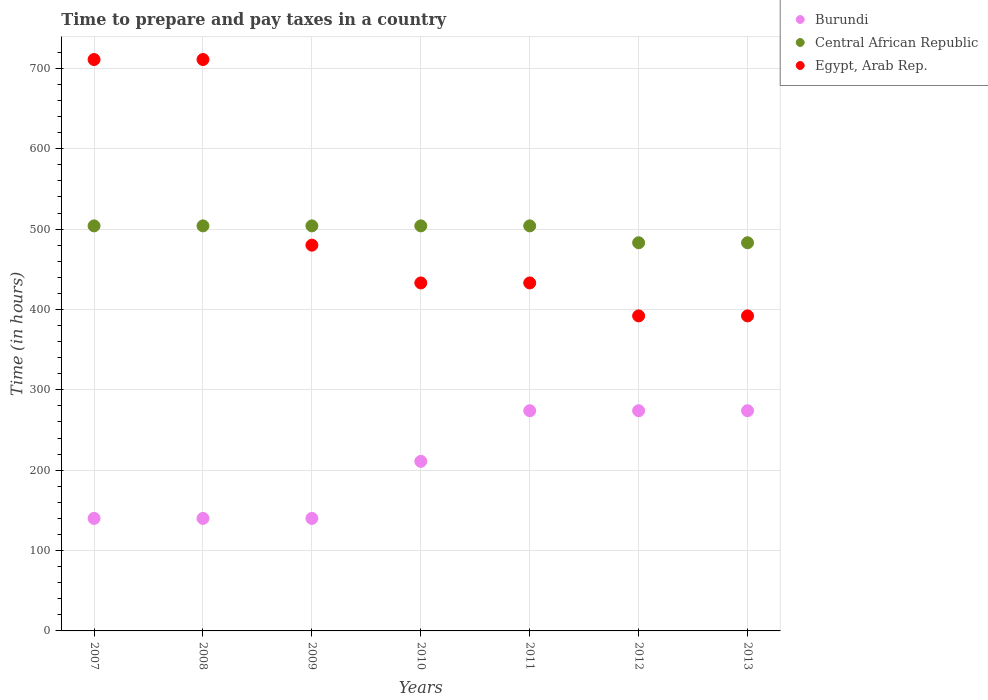Is the number of dotlines equal to the number of legend labels?
Offer a terse response. Yes. What is the number of hours required to prepare and pay taxes in Burundi in 2012?
Give a very brief answer. 274. Across all years, what is the maximum number of hours required to prepare and pay taxes in Egypt, Arab Rep.?
Your answer should be very brief. 711. Across all years, what is the minimum number of hours required to prepare and pay taxes in Burundi?
Ensure brevity in your answer.  140. In which year was the number of hours required to prepare and pay taxes in Burundi minimum?
Ensure brevity in your answer.  2007. What is the total number of hours required to prepare and pay taxes in Burundi in the graph?
Your answer should be compact. 1453. What is the difference between the number of hours required to prepare and pay taxes in Egypt, Arab Rep. in 2008 and that in 2011?
Provide a short and direct response. 278. What is the difference between the number of hours required to prepare and pay taxes in Egypt, Arab Rep. in 2008 and the number of hours required to prepare and pay taxes in Central African Republic in 2010?
Keep it short and to the point. 207. What is the average number of hours required to prepare and pay taxes in Burundi per year?
Provide a succinct answer. 207.57. In the year 2013, what is the difference between the number of hours required to prepare and pay taxes in Central African Republic and number of hours required to prepare and pay taxes in Egypt, Arab Rep.?
Offer a very short reply. 91. What is the ratio of the number of hours required to prepare and pay taxes in Burundi in 2010 to that in 2011?
Provide a short and direct response. 0.77. Is the difference between the number of hours required to prepare and pay taxes in Central African Republic in 2008 and 2010 greater than the difference between the number of hours required to prepare and pay taxes in Egypt, Arab Rep. in 2008 and 2010?
Your response must be concise. No. What is the difference between the highest and the second highest number of hours required to prepare and pay taxes in Burundi?
Provide a succinct answer. 0. What is the difference between the highest and the lowest number of hours required to prepare and pay taxes in Burundi?
Keep it short and to the point. 134. In how many years, is the number of hours required to prepare and pay taxes in Burundi greater than the average number of hours required to prepare and pay taxes in Burundi taken over all years?
Give a very brief answer. 4. Does the number of hours required to prepare and pay taxes in Egypt, Arab Rep. monotonically increase over the years?
Your response must be concise. No. Is the number of hours required to prepare and pay taxes in Burundi strictly greater than the number of hours required to prepare and pay taxes in Egypt, Arab Rep. over the years?
Make the answer very short. No. Is the number of hours required to prepare and pay taxes in Burundi strictly less than the number of hours required to prepare and pay taxes in Central African Republic over the years?
Your response must be concise. Yes. How many years are there in the graph?
Make the answer very short. 7. What is the difference between two consecutive major ticks on the Y-axis?
Give a very brief answer. 100. Are the values on the major ticks of Y-axis written in scientific E-notation?
Your response must be concise. No. Does the graph contain grids?
Make the answer very short. Yes. What is the title of the graph?
Provide a short and direct response. Time to prepare and pay taxes in a country. Does "Mauritania" appear as one of the legend labels in the graph?
Make the answer very short. No. What is the label or title of the X-axis?
Your answer should be very brief. Years. What is the label or title of the Y-axis?
Provide a succinct answer. Time (in hours). What is the Time (in hours) in Burundi in 2007?
Ensure brevity in your answer.  140. What is the Time (in hours) of Central African Republic in 2007?
Your response must be concise. 504. What is the Time (in hours) of Egypt, Arab Rep. in 2007?
Make the answer very short. 711. What is the Time (in hours) of Burundi in 2008?
Keep it short and to the point. 140. What is the Time (in hours) in Central African Republic in 2008?
Provide a succinct answer. 504. What is the Time (in hours) of Egypt, Arab Rep. in 2008?
Ensure brevity in your answer.  711. What is the Time (in hours) in Burundi in 2009?
Provide a short and direct response. 140. What is the Time (in hours) in Central African Republic in 2009?
Your answer should be very brief. 504. What is the Time (in hours) in Egypt, Arab Rep. in 2009?
Offer a terse response. 480. What is the Time (in hours) of Burundi in 2010?
Keep it short and to the point. 211. What is the Time (in hours) in Central African Republic in 2010?
Ensure brevity in your answer.  504. What is the Time (in hours) in Egypt, Arab Rep. in 2010?
Ensure brevity in your answer.  433. What is the Time (in hours) of Burundi in 2011?
Offer a terse response. 274. What is the Time (in hours) in Central African Republic in 2011?
Keep it short and to the point. 504. What is the Time (in hours) in Egypt, Arab Rep. in 2011?
Provide a short and direct response. 433. What is the Time (in hours) of Burundi in 2012?
Offer a terse response. 274. What is the Time (in hours) of Central African Republic in 2012?
Give a very brief answer. 483. What is the Time (in hours) of Egypt, Arab Rep. in 2012?
Your answer should be compact. 392. What is the Time (in hours) in Burundi in 2013?
Offer a terse response. 274. What is the Time (in hours) of Central African Republic in 2013?
Your response must be concise. 483. What is the Time (in hours) of Egypt, Arab Rep. in 2013?
Give a very brief answer. 392. Across all years, what is the maximum Time (in hours) of Burundi?
Your response must be concise. 274. Across all years, what is the maximum Time (in hours) in Central African Republic?
Your answer should be compact. 504. Across all years, what is the maximum Time (in hours) in Egypt, Arab Rep.?
Keep it short and to the point. 711. Across all years, what is the minimum Time (in hours) in Burundi?
Provide a succinct answer. 140. Across all years, what is the minimum Time (in hours) in Central African Republic?
Offer a terse response. 483. Across all years, what is the minimum Time (in hours) of Egypt, Arab Rep.?
Provide a succinct answer. 392. What is the total Time (in hours) in Burundi in the graph?
Give a very brief answer. 1453. What is the total Time (in hours) of Central African Republic in the graph?
Give a very brief answer. 3486. What is the total Time (in hours) in Egypt, Arab Rep. in the graph?
Provide a short and direct response. 3552. What is the difference between the Time (in hours) in Central African Republic in 2007 and that in 2008?
Provide a succinct answer. 0. What is the difference between the Time (in hours) in Burundi in 2007 and that in 2009?
Your answer should be very brief. 0. What is the difference between the Time (in hours) of Egypt, Arab Rep. in 2007 and that in 2009?
Your response must be concise. 231. What is the difference between the Time (in hours) of Burundi in 2007 and that in 2010?
Your answer should be very brief. -71. What is the difference between the Time (in hours) of Central African Republic in 2007 and that in 2010?
Keep it short and to the point. 0. What is the difference between the Time (in hours) of Egypt, Arab Rep. in 2007 and that in 2010?
Your answer should be compact. 278. What is the difference between the Time (in hours) of Burundi in 2007 and that in 2011?
Provide a short and direct response. -134. What is the difference between the Time (in hours) of Egypt, Arab Rep. in 2007 and that in 2011?
Your response must be concise. 278. What is the difference between the Time (in hours) of Burundi in 2007 and that in 2012?
Your answer should be compact. -134. What is the difference between the Time (in hours) of Egypt, Arab Rep. in 2007 and that in 2012?
Ensure brevity in your answer.  319. What is the difference between the Time (in hours) of Burundi in 2007 and that in 2013?
Your answer should be compact. -134. What is the difference between the Time (in hours) of Central African Republic in 2007 and that in 2013?
Your answer should be very brief. 21. What is the difference between the Time (in hours) of Egypt, Arab Rep. in 2007 and that in 2013?
Keep it short and to the point. 319. What is the difference between the Time (in hours) of Burundi in 2008 and that in 2009?
Give a very brief answer. 0. What is the difference between the Time (in hours) of Egypt, Arab Rep. in 2008 and that in 2009?
Provide a short and direct response. 231. What is the difference between the Time (in hours) in Burundi in 2008 and that in 2010?
Offer a very short reply. -71. What is the difference between the Time (in hours) of Central African Republic in 2008 and that in 2010?
Your answer should be very brief. 0. What is the difference between the Time (in hours) of Egypt, Arab Rep. in 2008 and that in 2010?
Provide a succinct answer. 278. What is the difference between the Time (in hours) of Burundi in 2008 and that in 2011?
Make the answer very short. -134. What is the difference between the Time (in hours) of Central African Republic in 2008 and that in 2011?
Ensure brevity in your answer.  0. What is the difference between the Time (in hours) in Egypt, Arab Rep. in 2008 and that in 2011?
Make the answer very short. 278. What is the difference between the Time (in hours) in Burundi in 2008 and that in 2012?
Provide a short and direct response. -134. What is the difference between the Time (in hours) of Central African Republic in 2008 and that in 2012?
Give a very brief answer. 21. What is the difference between the Time (in hours) in Egypt, Arab Rep. in 2008 and that in 2012?
Offer a terse response. 319. What is the difference between the Time (in hours) in Burundi in 2008 and that in 2013?
Offer a terse response. -134. What is the difference between the Time (in hours) in Central African Republic in 2008 and that in 2013?
Offer a very short reply. 21. What is the difference between the Time (in hours) of Egypt, Arab Rep. in 2008 and that in 2013?
Your response must be concise. 319. What is the difference between the Time (in hours) of Burundi in 2009 and that in 2010?
Your answer should be compact. -71. What is the difference between the Time (in hours) of Burundi in 2009 and that in 2011?
Keep it short and to the point. -134. What is the difference between the Time (in hours) in Central African Republic in 2009 and that in 2011?
Keep it short and to the point. 0. What is the difference between the Time (in hours) of Egypt, Arab Rep. in 2009 and that in 2011?
Provide a succinct answer. 47. What is the difference between the Time (in hours) of Burundi in 2009 and that in 2012?
Provide a succinct answer. -134. What is the difference between the Time (in hours) in Central African Republic in 2009 and that in 2012?
Make the answer very short. 21. What is the difference between the Time (in hours) of Burundi in 2009 and that in 2013?
Make the answer very short. -134. What is the difference between the Time (in hours) in Central African Republic in 2009 and that in 2013?
Your response must be concise. 21. What is the difference between the Time (in hours) in Egypt, Arab Rep. in 2009 and that in 2013?
Your answer should be very brief. 88. What is the difference between the Time (in hours) in Burundi in 2010 and that in 2011?
Offer a very short reply. -63. What is the difference between the Time (in hours) in Central African Republic in 2010 and that in 2011?
Give a very brief answer. 0. What is the difference between the Time (in hours) of Burundi in 2010 and that in 2012?
Ensure brevity in your answer.  -63. What is the difference between the Time (in hours) of Central African Republic in 2010 and that in 2012?
Offer a terse response. 21. What is the difference between the Time (in hours) in Burundi in 2010 and that in 2013?
Your answer should be very brief. -63. What is the difference between the Time (in hours) of Egypt, Arab Rep. in 2010 and that in 2013?
Give a very brief answer. 41. What is the difference between the Time (in hours) in Central African Republic in 2011 and that in 2013?
Ensure brevity in your answer.  21. What is the difference between the Time (in hours) of Egypt, Arab Rep. in 2011 and that in 2013?
Keep it short and to the point. 41. What is the difference between the Time (in hours) of Burundi in 2012 and that in 2013?
Your response must be concise. 0. What is the difference between the Time (in hours) in Central African Republic in 2012 and that in 2013?
Make the answer very short. 0. What is the difference between the Time (in hours) in Burundi in 2007 and the Time (in hours) in Central African Republic in 2008?
Ensure brevity in your answer.  -364. What is the difference between the Time (in hours) of Burundi in 2007 and the Time (in hours) of Egypt, Arab Rep. in 2008?
Offer a very short reply. -571. What is the difference between the Time (in hours) in Central African Republic in 2007 and the Time (in hours) in Egypt, Arab Rep. in 2008?
Make the answer very short. -207. What is the difference between the Time (in hours) of Burundi in 2007 and the Time (in hours) of Central African Republic in 2009?
Provide a short and direct response. -364. What is the difference between the Time (in hours) in Burundi in 2007 and the Time (in hours) in Egypt, Arab Rep. in 2009?
Provide a short and direct response. -340. What is the difference between the Time (in hours) in Burundi in 2007 and the Time (in hours) in Central African Republic in 2010?
Your answer should be compact. -364. What is the difference between the Time (in hours) of Burundi in 2007 and the Time (in hours) of Egypt, Arab Rep. in 2010?
Provide a succinct answer. -293. What is the difference between the Time (in hours) of Central African Republic in 2007 and the Time (in hours) of Egypt, Arab Rep. in 2010?
Offer a terse response. 71. What is the difference between the Time (in hours) in Burundi in 2007 and the Time (in hours) in Central African Republic in 2011?
Provide a short and direct response. -364. What is the difference between the Time (in hours) in Burundi in 2007 and the Time (in hours) in Egypt, Arab Rep. in 2011?
Give a very brief answer. -293. What is the difference between the Time (in hours) of Burundi in 2007 and the Time (in hours) of Central African Republic in 2012?
Keep it short and to the point. -343. What is the difference between the Time (in hours) in Burundi in 2007 and the Time (in hours) in Egypt, Arab Rep. in 2012?
Make the answer very short. -252. What is the difference between the Time (in hours) of Central African Republic in 2007 and the Time (in hours) of Egypt, Arab Rep. in 2012?
Keep it short and to the point. 112. What is the difference between the Time (in hours) of Burundi in 2007 and the Time (in hours) of Central African Republic in 2013?
Your answer should be very brief. -343. What is the difference between the Time (in hours) of Burundi in 2007 and the Time (in hours) of Egypt, Arab Rep. in 2013?
Give a very brief answer. -252. What is the difference between the Time (in hours) of Central African Republic in 2007 and the Time (in hours) of Egypt, Arab Rep. in 2013?
Your answer should be very brief. 112. What is the difference between the Time (in hours) in Burundi in 2008 and the Time (in hours) in Central African Republic in 2009?
Offer a very short reply. -364. What is the difference between the Time (in hours) in Burundi in 2008 and the Time (in hours) in Egypt, Arab Rep. in 2009?
Your answer should be compact. -340. What is the difference between the Time (in hours) in Burundi in 2008 and the Time (in hours) in Central African Republic in 2010?
Your answer should be compact. -364. What is the difference between the Time (in hours) in Burundi in 2008 and the Time (in hours) in Egypt, Arab Rep. in 2010?
Offer a terse response. -293. What is the difference between the Time (in hours) in Central African Republic in 2008 and the Time (in hours) in Egypt, Arab Rep. in 2010?
Your answer should be very brief. 71. What is the difference between the Time (in hours) of Burundi in 2008 and the Time (in hours) of Central African Republic in 2011?
Offer a very short reply. -364. What is the difference between the Time (in hours) in Burundi in 2008 and the Time (in hours) in Egypt, Arab Rep. in 2011?
Give a very brief answer. -293. What is the difference between the Time (in hours) in Burundi in 2008 and the Time (in hours) in Central African Republic in 2012?
Provide a succinct answer. -343. What is the difference between the Time (in hours) of Burundi in 2008 and the Time (in hours) of Egypt, Arab Rep. in 2012?
Your answer should be very brief. -252. What is the difference between the Time (in hours) in Central African Republic in 2008 and the Time (in hours) in Egypt, Arab Rep. in 2012?
Provide a short and direct response. 112. What is the difference between the Time (in hours) of Burundi in 2008 and the Time (in hours) of Central African Republic in 2013?
Offer a terse response. -343. What is the difference between the Time (in hours) of Burundi in 2008 and the Time (in hours) of Egypt, Arab Rep. in 2013?
Provide a succinct answer. -252. What is the difference between the Time (in hours) of Central African Republic in 2008 and the Time (in hours) of Egypt, Arab Rep. in 2013?
Your answer should be compact. 112. What is the difference between the Time (in hours) in Burundi in 2009 and the Time (in hours) in Central African Republic in 2010?
Offer a very short reply. -364. What is the difference between the Time (in hours) in Burundi in 2009 and the Time (in hours) in Egypt, Arab Rep. in 2010?
Offer a very short reply. -293. What is the difference between the Time (in hours) in Burundi in 2009 and the Time (in hours) in Central African Republic in 2011?
Offer a very short reply. -364. What is the difference between the Time (in hours) in Burundi in 2009 and the Time (in hours) in Egypt, Arab Rep. in 2011?
Your answer should be very brief. -293. What is the difference between the Time (in hours) in Central African Republic in 2009 and the Time (in hours) in Egypt, Arab Rep. in 2011?
Provide a short and direct response. 71. What is the difference between the Time (in hours) of Burundi in 2009 and the Time (in hours) of Central African Republic in 2012?
Make the answer very short. -343. What is the difference between the Time (in hours) in Burundi in 2009 and the Time (in hours) in Egypt, Arab Rep. in 2012?
Offer a very short reply. -252. What is the difference between the Time (in hours) of Central African Republic in 2009 and the Time (in hours) of Egypt, Arab Rep. in 2012?
Offer a very short reply. 112. What is the difference between the Time (in hours) in Burundi in 2009 and the Time (in hours) in Central African Republic in 2013?
Your answer should be very brief. -343. What is the difference between the Time (in hours) in Burundi in 2009 and the Time (in hours) in Egypt, Arab Rep. in 2013?
Make the answer very short. -252. What is the difference between the Time (in hours) of Central African Republic in 2009 and the Time (in hours) of Egypt, Arab Rep. in 2013?
Keep it short and to the point. 112. What is the difference between the Time (in hours) in Burundi in 2010 and the Time (in hours) in Central African Republic in 2011?
Provide a succinct answer. -293. What is the difference between the Time (in hours) of Burundi in 2010 and the Time (in hours) of Egypt, Arab Rep. in 2011?
Your answer should be compact. -222. What is the difference between the Time (in hours) in Burundi in 2010 and the Time (in hours) in Central African Republic in 2012?
Offer a terse response. -272. What is the difference between the Time (in hours) of Burundi in 2010 and the Time (in hours) of Egypt, Arab Rep. in 2012?
Provide a succinct answer. -181. What is the difference between the Time (in hours) in Central African Republic in 2010 and the Time (in hours) in Egypt, Arab Rep. in 2012?
Your response must be concise. 112. What is the difference between the Time (in hours) of Burundi in 2010 and the Time (in hours) of Central African Republic in 2013?
Your answer should be very brief. -272. What is the difference between the Time (in hours) in Burundi in 2010 and the Time (in hours) in Egypt, Arab Rep. in 2013?
Provide a succinct answer. -181. What is the difference between the Time (in hours) of Central African Republic in 2010 and the Time (in hours) of Egypt, Arab Rep. in 2013?
Provide a succinct answer. 112. What is the difference between the Time (in hours) in Burundi in 2011 and the Time (in hours) in Central African Republic in 2012?
Ensure brevity in your answer.  -209. What is the difference between the Time (in hours) in Burundi in 2011 and the Time (in hours) in Egypt, Arab Rep. in 2012?
Keep it short and to the point. -118. What is the difference between the Time (in hours) of Central African Republic in 2011 and the Time (in hours) of Egypt, Arab Rep. in 2012?
Make the answer very short. 112. What is the difference between the Time (in hours) of Burundi in 2011 and the Time (in hours) of Central African Republic in 2013?
Offer a very short reply. -209. What is the difference between the Time (in hours) in Burundi in 2011 and the Time (in hours) in Egypt, Arab Rep. in 2013?
Keep it short and to the point. -118. What is the difference between the Time (in hours) of Central African Republic in 2011 and the Time (in hours) of Egypt, Arab Rep. in 2013?
Make the answer very short. 112. What is the difference between the Time (in hours) in Burundi in 2012 and the Time (in hours) in Central African Republic in 2013?
Offer a very short reply. -209. What is the difference between the Time (in hours) in Burundi in 2012 and the Time (in hours) in Egypt, Arab Rep. in 2013?
Your answer should be compact. -118. What is the difference between the Time (in hours) of Central African Republic in 2012 and the Time (in hours) of Egypt, Arab Rep. in 2013?
Your answer should be compact. 91. What is the average Time (in hours) of Burundi per year?
Ensure brevity in your answer.  207.57. What is the average Time (in hours) of Central African Republic per year?
Provide a succinct answer. 498. What is the average Time (in hours) of Egypt, Arab Rep. per year?
Offer a very short reply. 507.43. In the year 2007, what is the difference between the Time (in hours) of Burundi and Time (in hours) of Central African Republic?
Provide a short and direct response. -364. In the year 2007, what is the difference between the Time (in hours) in Burundi and Time (in hours) in Egypt, Arab Rep.?
Your answer should be compact. -571. In the year 2007, what is the difference between the Time (in hours) of Central African Republic and Time (in hours) of Egypt, Arab Rep.?
Make the answer very short. -207. In the year 2008, what is the difference between the Time (in hours) in Burundi and Time (in hours) in Central African Republic?
Ensure brevity in your answer.  -364. In the year 2008, what is the difference between the Time (in hours) of Burundi and Time (in hours) of Egypt, Arab Rep.?
Offer a very short reply. -571. In the year 2008, what is the difference between the Time (in hours) in Central African Republic and Time (in hours) in Egypt, Arab Rep.?
Provide a succinct answer. -207. In the year 2009, what is the difference between the Time (in hours) of Burundi and Time (in hours) of Central African Republic?
Your response must be concise. -364. In the year 2009, what is the difference between the Time (in hours) in Burundi and Time (in hours) in Egypt, Arab Rep.?
Your answer should be very brief. -340. In the year 2009, what is the difference between the Time (in hours) in Central African Republic and Time (in hours) in Egypt, Arab Rep.?
Your answer should be very brief. 24. In the year 2010, what is the difference between the Time (in hours) in Burundi and Time (in hours) in Central African Republic?
Your response must be concise. -293. In the year 2010, what is the difference between the Time (in hours) in Burundi and Time (in hours) in Egypt, Arab Rep.?
Offer a terse response. -222. In the year 2010, what is the difference between the Time (in hours) of Central African Republic and Time (in hours) of Egypt, Arab Rep.?
Give a very brief answer. 71. In the year 2011, what is the difference between the Time (in hours) in Burundi and Time (in hours) in Central African Republic?
Ensure brevity in your answer.  -230. In the year 2011, what is the difference between the Time (in hours) in Burundi and Time (in hours) in Egypt, Arab Rep.?
Offer a very short reply. -159. In the year 2012, what is the difference between the Time (in hours) in Burundi and Time (in hours) in Central African Republic?
Make the answer very short. -209. In the year 2012, what is the difference between the Time (in hours) of Burundi and Time (in hours) of Egypt, Arab Rep.?
Make the answer very short. -118. In the year 2012, what is the difference between the Time (in hours) in Central African Republic and Time (in hours) in Egypt, Arab Rep.?
Your answer should be very brief. 91. In the year 2013, what is the difference between the Time (in hours) in Burundi and Time (in hours) in Central African Republic?
Give a very brief answer. -209. In the year 2013, what is the difference between the Time (in hours) in Burundi and Time (in hours) in Egypt, Arab Rep.?
Your response must be concise. -118. In the year 2013, what is the difference between the Time (in hours) of Central African Republic and Time (in hours) of Egypt, Arab Rep.?
Ensure brevity in your answer.  91. What is the ratio of the Time (in hours) in Burundi in 2007 to that in 2009?
Your answer should be compact. 1. What is the ratio of the Time (in hours) of Central African Republic in 2007 to that in 2009?
Offer a terse response. 1. What is the ratio of the Time (in hours) in Egypt, Arab Rep. in 2007 to that in 2009?
Your response must be concise. 1.48. What is the ratio of the Time (in hours) in Burundi in 2007 to that in 2010?
Your answer should be very brief. 0.66. What is the ratio of the Time (in hours) of Egypt, Arab Rep. in 2007 to that in 2010?
Your response must be concise. 1.64. What is the ratio of the Time (in hours) in Burundi in 2007 to that in 2011?
Provide a succinct answer. 0.51. What is the ratio of the Time (in hours) of Egypt, Arab Rep. in 2007 to that in 2011?
Keep it short and to the point. 1.64. What is the ratio of the Time (in hours) in Burundi in 2007 to that in 2012?
Your answer should be very brief. 0.51. What is the ratio of the Time (in hours) of Central African Republic in 2007 to that in 2012?
Give a very brief answer. 1.04. What is the ratio of the Time (in hours) of Egypt, Arab Rep. in 2007 to that in 2012?
Ensure brevity in your answer.  1.81. What is the ratio of the Time (in hours) of Burundi in 2007 to that in 2013?
Make the answer very short. 0.51. What is the ratio of the Time (in hours) of Central African Republic in 2007 to that in 2013?
Your response must be concise. 1.04. What is the ratio of the Time (in hours) of Egypt, Arab Rep. in 2007 to that in 2013?
Your response must be concise. 1.81. What is the ratio of the Time (in hours) in Burundi in 2008 to that in 2009?
Your answer should be compact. 1. What is the ratio of the Time (in hours) in Egypt, Arab Rep. in 2008 to that in 2009?
Provide a short and direct response. 1.48. What is the ratio of the Time (in hours) of Burundi in 2008 to that in 2010?
Give a very brief answer. 0.66. What is the ratio of the Time (in hours) in Central African Republic in 2008 to that in 2010?
Offer a terse response. 1. What is the ratio of the Time (in hours) of Egypt, Arab Rep. in 2008 to that in 2010?
Offer a very short reply. 1.64. What is the ratio of the Time (in hours) of Burundi in 2008 to that in 2011?
Your answer should be compact. 0.51. What is the ratio of the Time (in hours) in Central African Republic in 2008 to that in 2011?
Offer a terse response. 1. What is the ratio of the Time (in hours) of Egypt, Arab Rep. in 2008 to that in 2011?
Provide a short and direct response. 1.64. What is the ratio of the Time (in hours) of Burundi in 2008 to that in 2012?
Keep it short and to the point. 0.51. What is the ratio of the Time (in hours) in Central African Republic in 2008 to that in 2012?
Your response must be concise. 1.04. What is the ratio of the Time (in hours) in Egypt, Arab Rep. in 2008 to that in 2012?
Give a very brief answer. 1.81. What is the ratio of the Time (in hours) in Burundi in 2008 to that in 2013?
Provide a short and direct response. 0.51. What is the ratio of the Time (in hours) in Central African Republic in 2008 to that in 2013?
Make the answer very short. 1.04. What is the ratio of the Time (in hours) of Egypt, Arab Rep. in 2008 to that in 2013?
Your answer should be compact. 1.81. What is the ratio of the Time (in hours) in Burundi in 2009 to that in 2010?
Your answer should be compact. 0.66. What is the ratio of the Time (in hours) of Central African Republic in 2009 to that in 2010?
Make the answer very short. 1. What is the ratio of the Time (in hours) in Egypt, Arab Rep. in 2009 to that in 2010?
Keep it short and to the point. 1.11. What is the ratio of the Time (in hours) in Burundi in 2009 to that in 2011?
Ensure brevity in your answer.  0.51. What is the ratio of the Time (in hours) in Central African Republic in 2009 to that in 2011?
Keep it short and to the point. 1. What is the ratio of the Time (in hours) in Egypt, Arab Rep. in 2009 to that in 2011?
Your response must be concise. 1.11. What is the ratio of the Time (in hours) in Burundi in 2009 to that in 2012?
Your answer should be very brief. 0.51. What is the ratio of the Time (in hours) in Central African Republic in 2009 to that in 2012?
Keep it short and to the point. 1.04. What is the ratio of the Time (in hours) of Egypt, Arab Rep. in 2009 to that in 2012?
Provide a short and direct response. 1.22. What is the ratio of the Time (in hours) in Burundi in 2009 to that in 2013?
Provide a short and direct response. 0.51. What is the ratio of the Time (in hours) in Central African Republic in 2009 to that in 2013?
Ensure brevity in your answer.  1.04. What is the ratio of the Time (in hours) of Egypt, Arab Rep. in 2009 to that in 2013?
Provide a short and direct response. 1.22. What is the ratio of the Time (in hours) of Burundi in 2010 to that in 2011?
Keep it short and to the point. 0.77. What is the ratio of the Time (in hours) of Egypt, Arab Rep. in 2010 to that in 2011?
Provide a short and direct response. 1. What is the ratio of the Time (in hours) of Burundi in 2010 to that in 2012?
Provide a short and direct response. 0.77. What is the ratio of the Time (in hours) of Central African Republic in 2010 to that in 2012?
Offer a terse response. 1.04. What is the ratio of the Time (in hours) in Egypt, Arab Rep. in 2010 to that in 2012?
Provide a succinct answer. 1.1. What is the ratio of the Time (in hours) of Burundi in 2010 to that in 2013?
Your answer should be compact. 0.77. What is the ratio of the Time (in hours) in Central African Republic in 2010 to that in 2013?
Keep it short and to the point. 1.04. What is the ratio of the Time (in hours) in Egypt, Arab Rep. in 2010 to that in 2013?
Keep it short and to the point. 1.1. What is the ratio of the Time (in hours) in Central African Republic in 2011 to that in 2012?
Offer a very short reply. 1.04. What is the ratio of the Time (in hours) of Egypt, Arab Rep. in 2011 to that in 2012?
Make the answer very short. 1.1. What is the ratio of the Time (in hours) of Central African Republic in 2011 to that in 2013?
Offer a very short reply. 1.04. What is the ratio of the Time (in hours) in Egypt, Arab Rep. in 2011 to that in 2013?
Your response must be concise. 1.1. What is the ratio of the Time (in hours) of Burundi in 2012 to that in 2013?
Offer a terse response. 1. What is the difference between the highest and the second highest Time (in hours) of Burundi?
Keep it short and to the point. 0. What is the difference between the highest and the second highest Time (in hours) in Egypt, Arab Rep.?
Ensure brevity in your answer.  0. What is the difference between the highest and the lowest Time (in hours) in Burundi?
Keep it short and to the point. 134. What is the difference between the highest and the lowest Time (in hours) in Central African Republic?
Ensure brevity in your answer.  21. What is the difference between the highest and the lowest Time (in hours) in Egypt, Arab Rep.?
Your response must be concise. 319. 